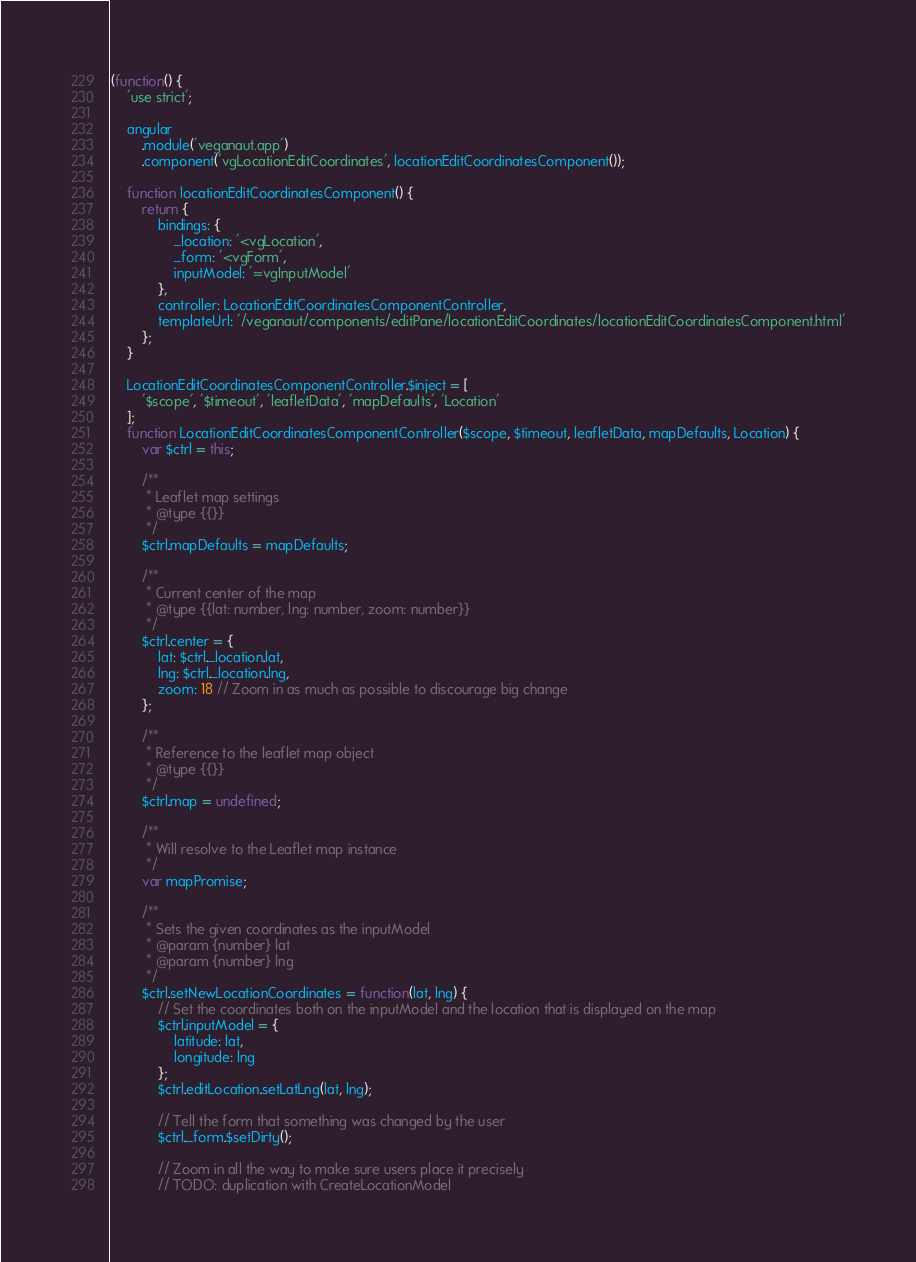<code> <loc_0><loc_0><loc_500><loc_500><_JavaScript_>(function() {
    'use strict';

    angular
        .module('veganaut.app')
        .component('vgLocationEditCoordinates', locationEditCoordinatesComponent());

    function locationEditCoordinatesComponent() {
        return {
            bindings: {
                _location: '<vgLocation',
                _form: '<vgForm',
                inputModel: '=vgInputModel'
            },
            controller: LocationEditCoordinatesComponentController,
            templateUrl: '/veganaut/components/editPane/locationEditCoordinates/locationEditCoordinatesComponent.html'
        };
    }

    LocationEditCoordinatesComponentController.$inject = [
        '$scope', '$timeout', 'leafletData', 'mapDefaults', 'Location'
    ];
    function LocationEditCoordinatesComponentController($scope, $timeout, leafletData, mapDefaults, Location) {
        var $ctrl = this;

        /**
         * Leaflet map settings
         * @type {{}}
         */
        $ctrl.mapDefaults = mapDefaults;

        /**
         * Current center of the map
         * @type {{lat: number, lng: number, zoom: number}}
         */
        $ctrl.center = {
            lat: $ctrl._location.lat,
            lng: $ctrl._location.lng,
            zoom: 18 // Zoom in as much as possible to discourage big change
        };

        /**
         * Reference to the leaflet map object
         * @type {{}}
         */
        $ctrl.map = undefined;

        /**
         * Will resolve to the Leaflet map instance
         */
        var mapPromise;

        /**
         * Sets the given coordinates as the inputModel
         * @param {number} lat
         * @param {number} lng
         */
        $ctrl.setNewLocationCoordinates = function(lat, lng) {
            // Set the coordinates both on the inputModel and the location that is displayed on the map
            $ctrl.inputModel = {
                latitude: lat,
                longitude: lng
            };
            $ctrl.editLocation.setLatLng(lat, lng);

            // Tell the form that something was changed by the user
            $ctrl._form.$setDirty();

            // Zoom in all the way to make sure users place it precisely
            // TODO: duplication with CreateLocationModel</code> 